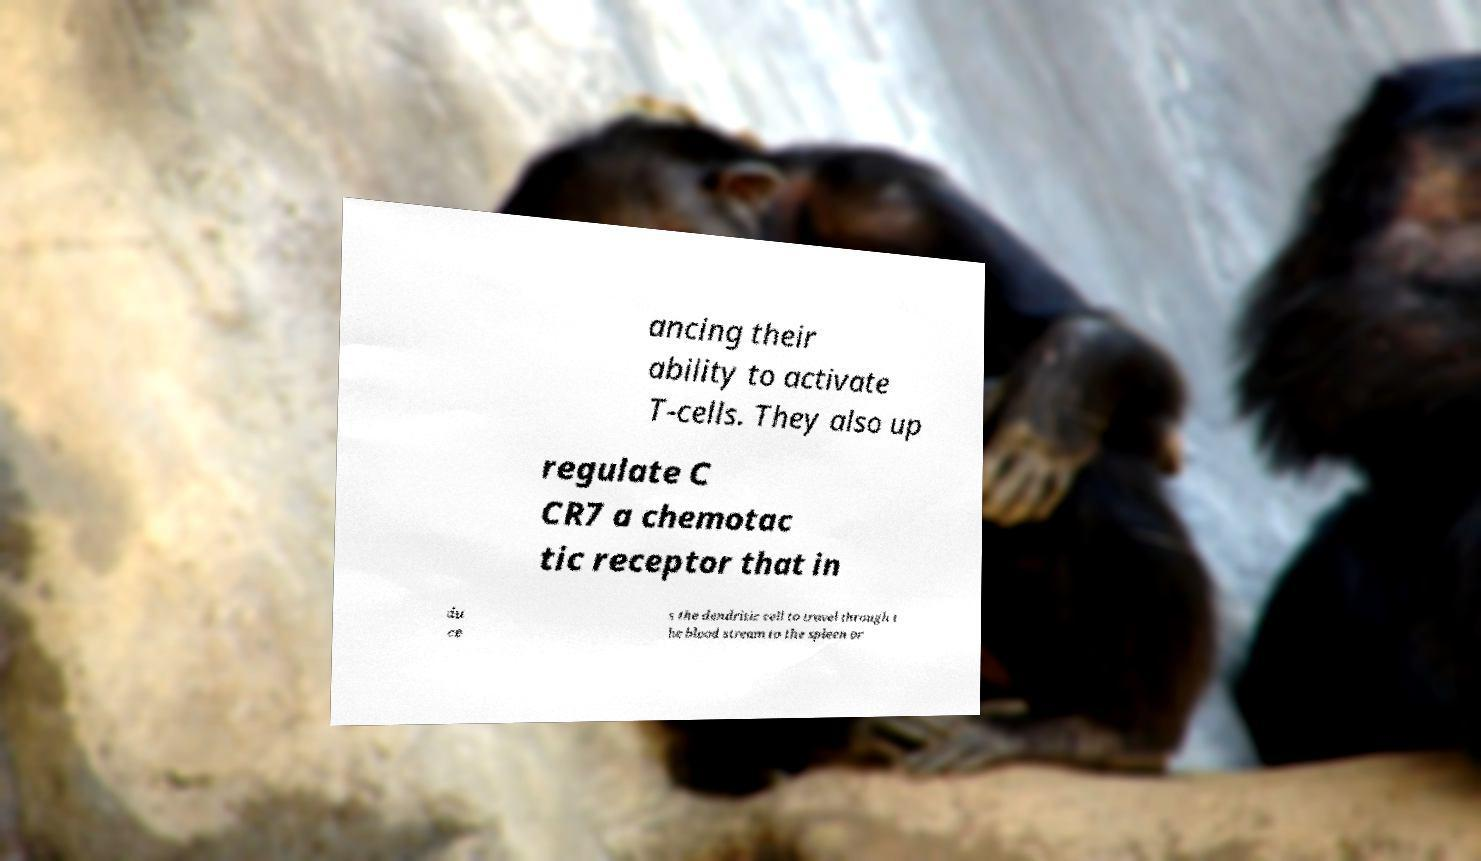There's text embedded in this image that I need extracted. Can you transcribe it verbatim? ancing their ability to activate T-cells. They also up regulate C CR7 a chemotac tic receptor that in du ce s the dendritic cell to travel through t he blood stream to the spleen or 